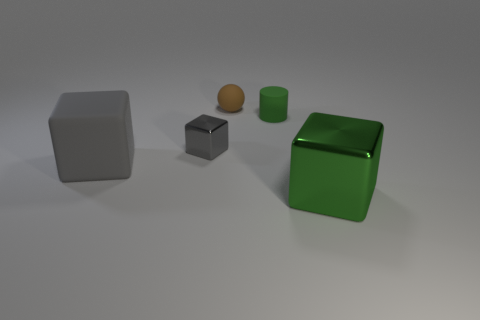How might the size of these objects compare to everyday items? While the exact scale isn't specified, the gray cube might be likened to a standard dice, the green cylinder could resemble a short can of soda, and the small objects could be compared to marbles. Of course, this is speculative without a point of reference. 